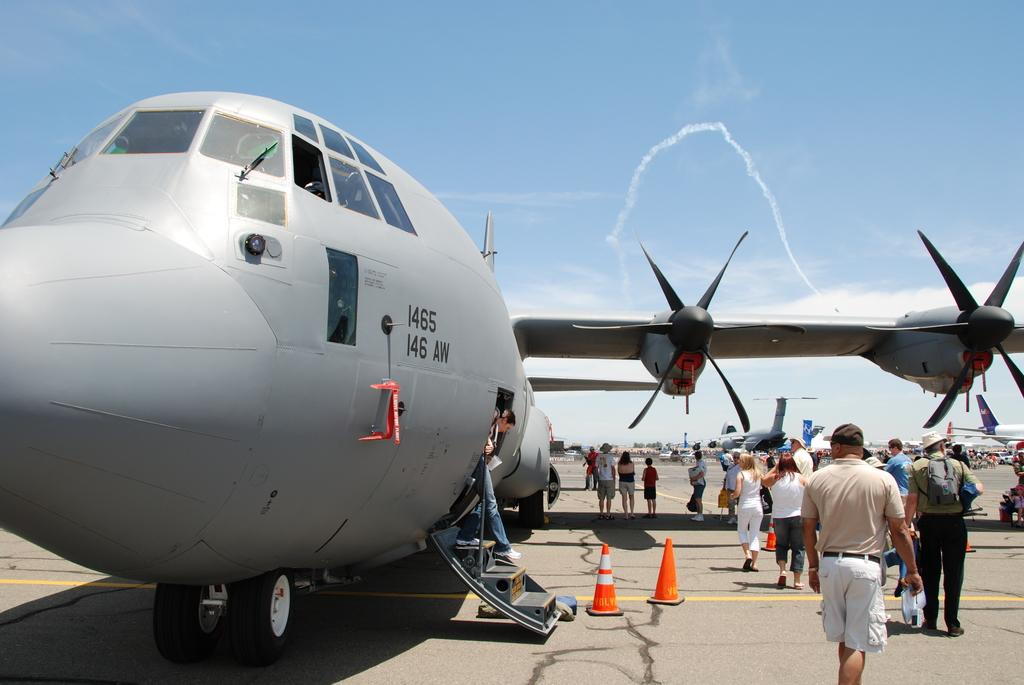<image>
Describe the image concisely. People are getting off a propeller plane marked 1465 146 AW. 